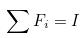Convert formula to latex. <formula><loc_0><loc_0><loc_500><loc_500>\sum F _ { i } = I</formula> 